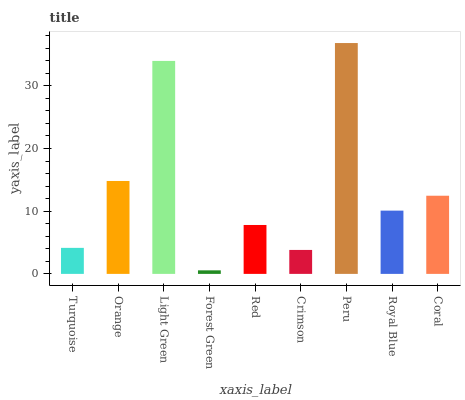Is Forest Green the minimum?
Answer yes or no. Yes. Is Peru the maximum?
Answer yes or no. Yes. Is Orange the minimum?
Answer yes or no. No. Is Orange the maximum?
Answer yes or no. No. Is Orange greater than Turquoise?
Answer yes or no. Yes. Is Turquoise less than Orange?
Answer yes or no. Yes. Is Turquoise greater than Orange?
Answer yes or no. No. Is Orange less than Turquoise?
Answer yes or no. No. Is Royal Blue the high median?
Answer yes or no. Yes. Is Royal Blue the low median?
Answer yes or no. Yes. Is Orange the high median?
Answer yes or no. No. Is Peru the low median?
Answer yes or no. No. 